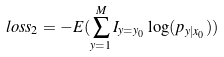Convert formula to latex. <formula><loc_0><loc_0><loc_500><loc_500>l o s s _ { 2 } = - E ( \sum _ { y = 1 } ^ { M } I _ { y = y _ { 0 } } \log ( p _ { y | x _ { 0 } } ) )</formula> 